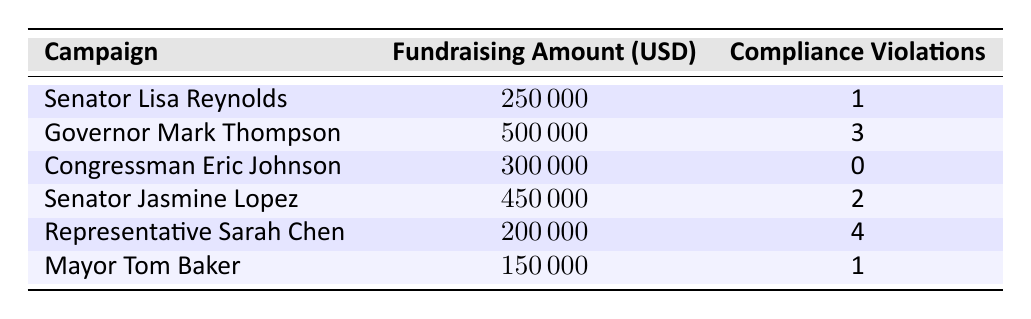What is the fundraising amount for Senator Jasmine Lopez? In the table, the row corresponding to Senator Jasmine Lopez shows a fundraising amount of 450000 USD.
Answer: 450000 How many compliance violations did Congressman Eric Johnson have? The row for Congressman Eric Johnson indicates that he had 0 compliance violations listed next to his campaign.
Answer: 0 What is the total fundraising amount for all campaigns combined? The fundraising amounts are as follows: 250000 + 500000 + 300000 + 450000 + 200000 + 150000 = 1850000 USD.
Answer: 1850000 Which campaign had the highest number of compliance violations? By examining the compliance violations for each campaign, Representative Sarah Chen has the highest with 4 violations.
Answer: Representative Sarah Chen Is it true that more fundraising is associated with higher compliance violations based on the data? Looking at correlation, Governor Mark Thompson has a high fundraising amount of 500000 USD and 3 violations, while Congressman Eric Johnson raised 300000 USD with 0 violations. Hence, the relationship isn't clear and requires more data for definitive conclusions.
Answer: No What is the average amount of fundraising for campaigns with 1 compliance violation? The campaigns with 1 compliance violation are Senator Lisa Reynolds and Mayor Tom Baker. Adding their fundraising amounts: 250000 + 150000 = 400000. To find the average, divide by the number of campaigns (2): 400000 / 2 = 200000 USD.
Answer: 200000 How many campaigns had compliance violations greater than 1? The table shows that the campaigns with more than 1 compliance violation are Governor Mark Thompson, Senator Jasmine Lopez, and Representative Sarah Chen, totaling 3 campaigns.
Answer: 3 What is the difference in fundraising amounts between the campaign with the most violations and the campaign with the least violations? The campaign with the most violations is Representative Sarah Chen (4 violations, 200000 USD), and the least is Congressman Eric Johnson (0 violations, 300000 USD). The difference is 300000 - 200000 = 100000 USD.
Answer: 100000 Do any campaigns have the same fundraising amount? Upon reviewing the table, all campaigns have unique fundraising amounts; hence, no two campaigns match.
Answer: No 